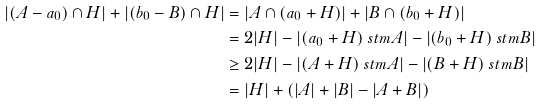<formula> <loc_0><loc_0><loc_500><loc_500>| ( A - a _ { 0 } ) \cap H | + | ( b _ { 0 } - B ) \cap H | & = | A \cap ( a _ { 0 } + H ) | + | B \cap ( b _ { 0 } + H ) | \\ & = 2 | H | - | ( a _ { 0 } + H ) \ s t m A | - | ( b _ { 0 } + H ) \ s t m B | \\ & \geq 2 | H | - | ( A + H ) \ s t m A | - | ( B + H ) \ s t m B | \\ & = | H | + ( | A | + | B | - | A + B | )</formula> 